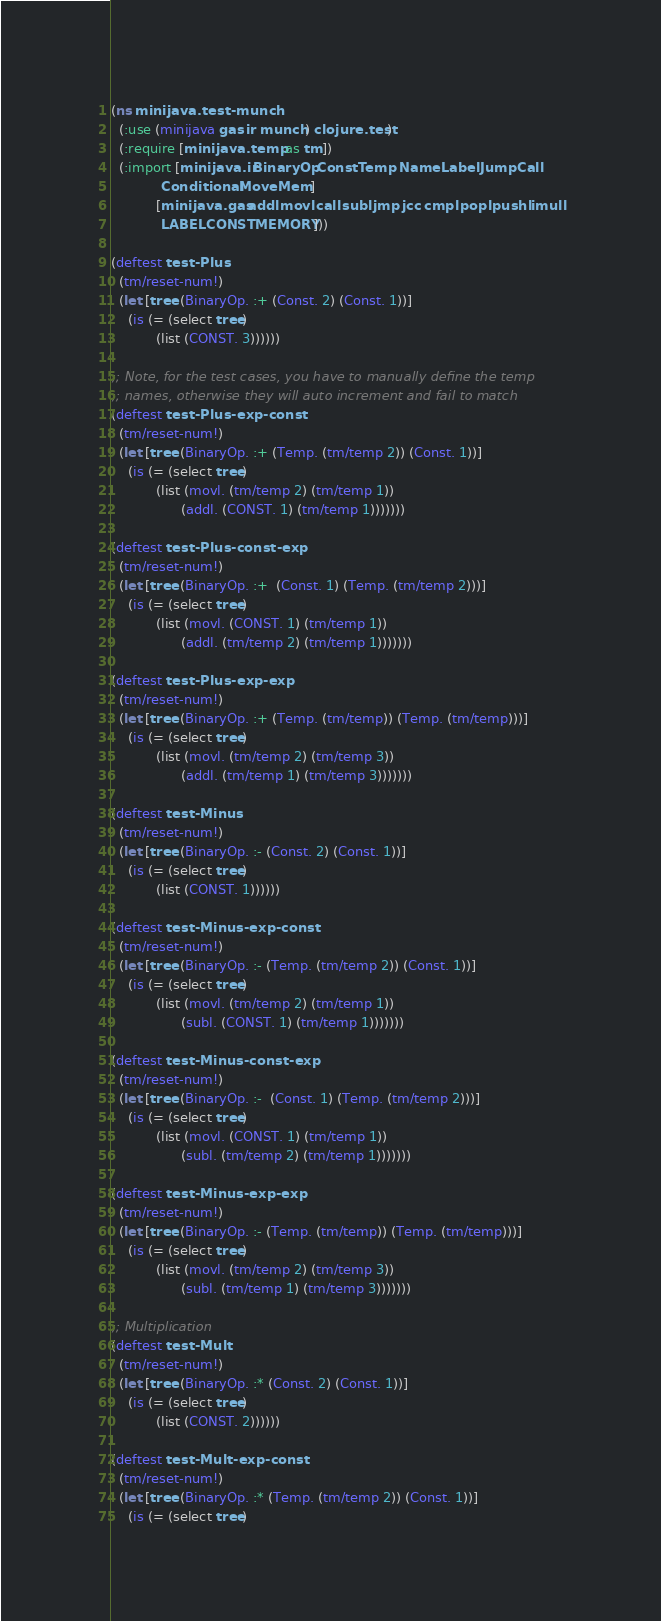Convert code to text. <code><loc_0><loc_0><loc_500><loc_500><_Clojure_>(ns minijava.test-munch
  (:use (minijava gas ir munch) clojure.test)
  (:require [minijava.temp :as tm])
  (:import [minijava.ir BinaryOp Const Temp Name Label Jump Call
            Conditional Move Mem]
           [minijava.gas addl movl call subl jmp jcc cmpl popl pushl imull
            LABEL CONST MEMORY]))

(deftest test-Plus
  (tm/reset-num!)
  (let [tree (BinaryOp. :+ (Const. 2) (Const. 1))]
    (is (= (select tree)
           (list (CONST. 3))))))

;; Note, for the test cases, you have to manually define the temp
;; names, otherwise they will auto increment and fail to match
(deftest test-Plus-exp-const
  (tm/reset-num!)
  (let [tree (BinaryOp. :+ (Temp. (tm/temp 2)) (Const. 1))]
    (is (= (select tree)
           (list (movl. (tm/temp 2) (tm/temp 1))
                 (addl. (CONST. 1) (tm/temp 1)))))))

(deftest test-Plus-const-exp
  (tm/reset-num!)
  (let [tree (BinaryOp. :+  (Const. 1) (Temp. (tm/temp 2)))]
    (is (= (select tree)
           (list (movl. (CONST. 1) (tm/temp 1))
                 (addl. (tm/temp 2) (tm/temp 1)))))))

(deftest test-Plus-exp-exp
  (tm/reset-num!)
  (let [tree (BinaryOp. :+ (Temp. (tm/temp)) (Temp. (tm/temp)))]
    (is (= (select tree)
           (list (movl. (tm/temp 2) (tm/temp 3))
                 (addl. (tm/temp 1) (tm/temp 3)))))))

(deftest test-Minus
  (tm/reset-num!)
  (let [tree (BinaryOp. :- (Const. 2) (Const. 1))]
    (is (= (select tree)
           (list (CONST. 1))))))

(deftest test-Minus-exp-const
  (tm/reset-num!)
  (let [tree (BinaryOp. :- (Temp. (tm/temp 2)) (Const. 1))]
    (is (= (select tree)
           (list (movl. (tm/temp 2) (tm/temp 1))
                 (subl. (CONST. 1) (tm/temp 1)))))))

(deftest test-Minus-const-exp
  (tm/reset-num!)
  (let [tree (BinaryOp. :-  (Const. 1) (Temp. (tm/temp 2)))]
    (is (= (select tree)
           (list (movl. (CONST. 1) (tm/temp 1))
                 (subl. (tm/temp 2) (tm/temp 1)))))))

(deftest test-Minus-exp-exp
  (tm/reset-num!)
  (let [tree (BinaryOp. :- (Temp. (tm/temp)) (Temp. (tm/temp)))]
    (is (= (select tree)
           (list (movl. (tm/temp 2) (tm/temp 3))
                 (subl. (tm/temp 1) (tm/temp 3)))))))

;; Multiplication
(deftest test-Mult
  (tm/reset-num!)
  (let [tree (BinaryOp. :* (Const. 2) (Const. 1))]
    (is (= (select tree)
           (list (CONST. 2))))))

(deftest test-Mult-exp-const
  (tm/reset-num!)
  (let [tree (BinaryOp. :* (Temp. (tm/temp 2)) (Const. 1))]
    (is (= (select tree)</code> 